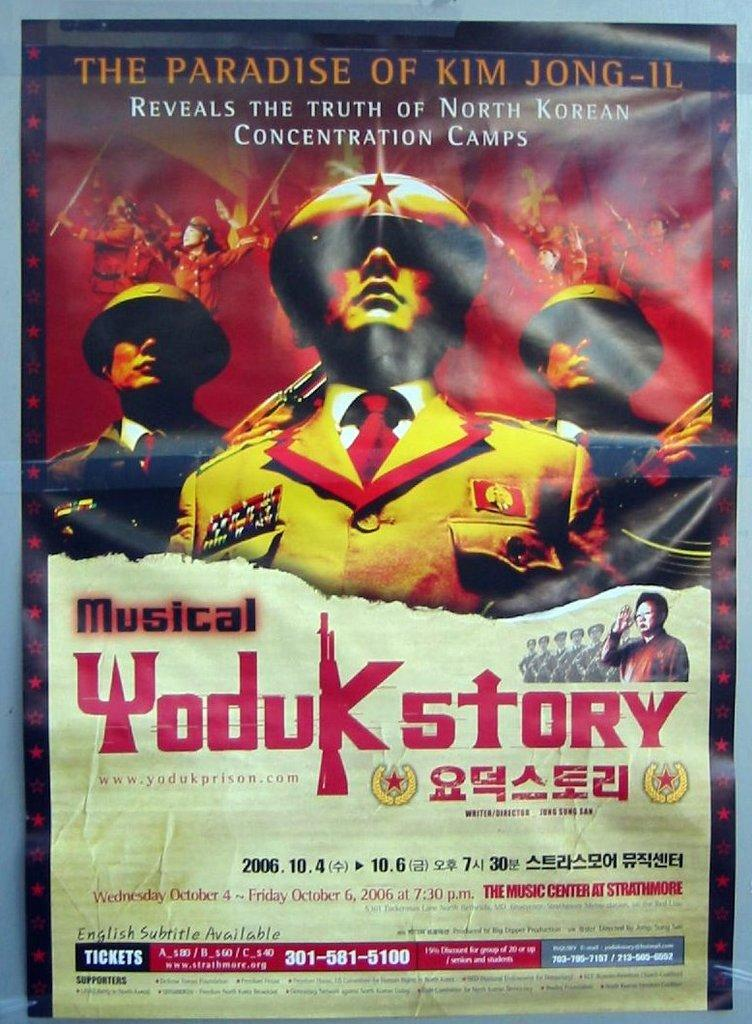<image>
Describe the image concisely. An event for the Paradise of Kim Jong is scheduled for 2006. 